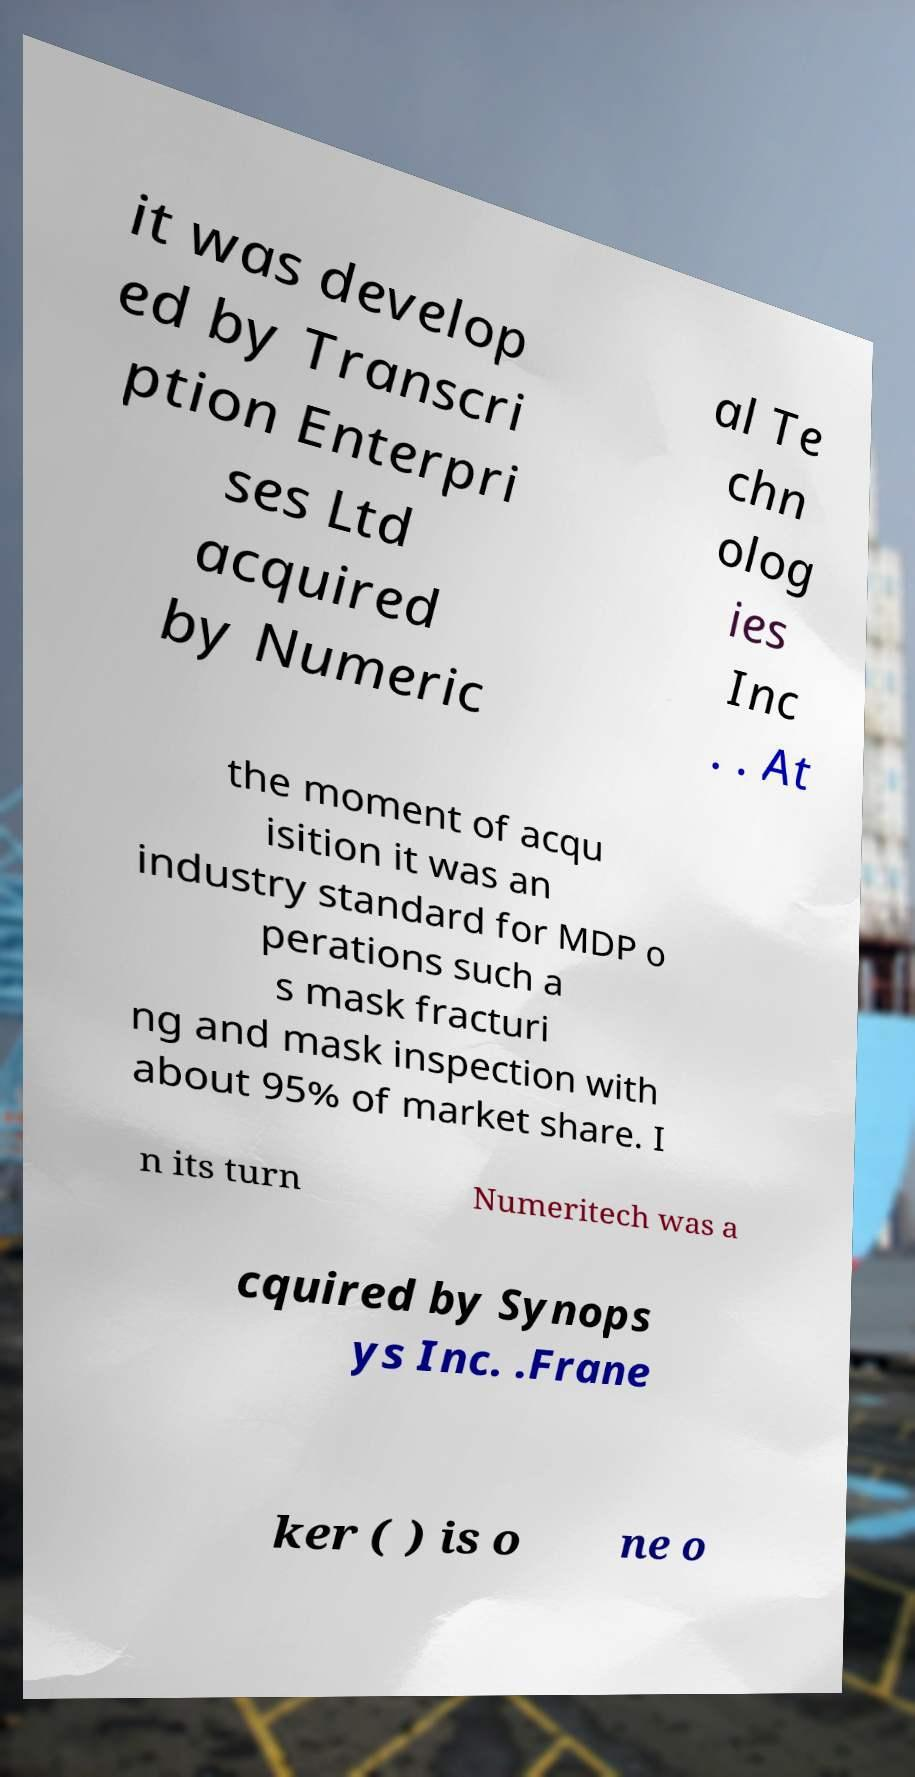Could you extract and type out the text from this image? it was develop ed by Transcri ption Enterpri ses Ltd acquired by Numeric al Te chn olog ies Inc . . At the moment of acqu isition it was an industry standard for MDP o perations such a s mask fracturi ng and mask inspection with about 95% of market share. I n its turn Numeritech was a cquired by Synops ys Inc. .Frane ker ( ) is o ne o 